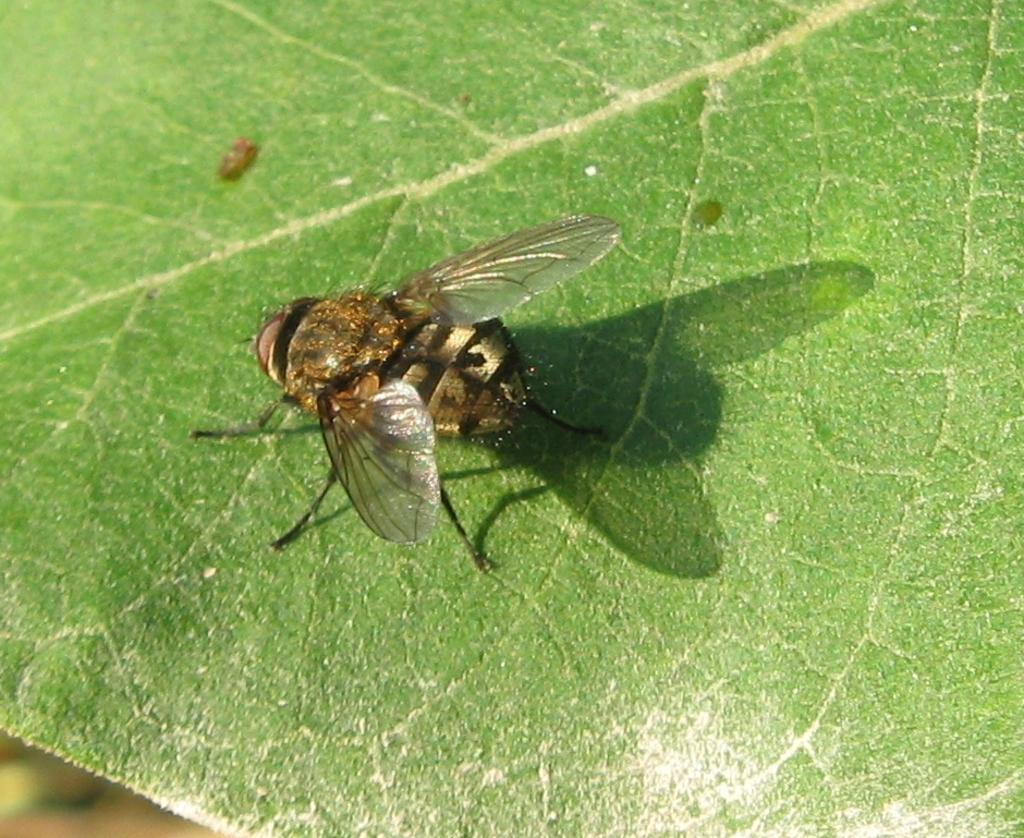What is the main subject of the image? The main subject of the image is a housefly. Where is the housefly located in the image? The housefly is sitting on a leaf. What type of drug is the housefly distributing in the image? There is no drug present in the image, and the housefly is not distributing anything. 